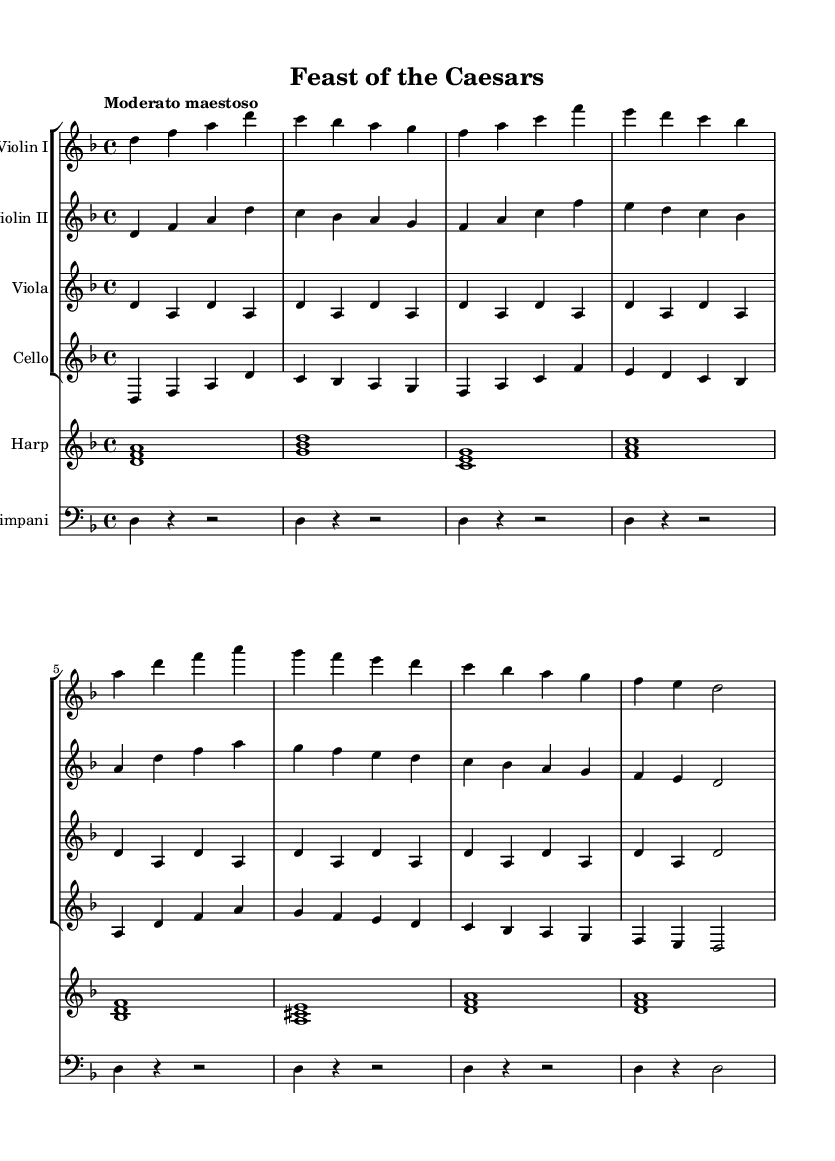What is the key signature of this music? The key signature indicated in the music sheet is D minor, which typically features one flat. This can be confirmed by examining the key signature at the beginning of the staff.
Answer: D minor What is the time signature of the piece? The time signature shown at the beginning of the music is 4/4, which means there are four beats in each measure and a quarter note receives one beat.
Answer: 4/4 What is the tempo marking of this piece? The tempo marking specifies "Moderato maestoso", indicating a moderately slow and majestic pace. This is noted at the beginning of the score.
Answer: Moderato maestoso Which instruments are featured in this composition? The instruments can be identified by their names written at the beginning of each staff, which includes Violin I, Violin II, Viola, Cello, Harp, and Timpani.
Answer: Violin I, Violin II, Viola, Cello, Harp, Timpani How many measures are in the violin parts? By counting the measures in the Violin I and Violin II staves, each contains a total of 8 measures. This can be quickly assessed by looking at the number of bar lines present in each part.
Answer: 8 measures What is the rhythmic value of the first note in the harp part? The first note played in the harp part is a whole note, indicated by the duration of the note that occupies the entire measure. This can be confirmed by observing the length of the note in the context of the 4/4 time signature.
Answer: Whole note 